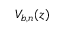Convert formula to latex. <formula><loc_0><loc_0><loc_500><loc_500>V _ { b , n } ( z )</formula> 